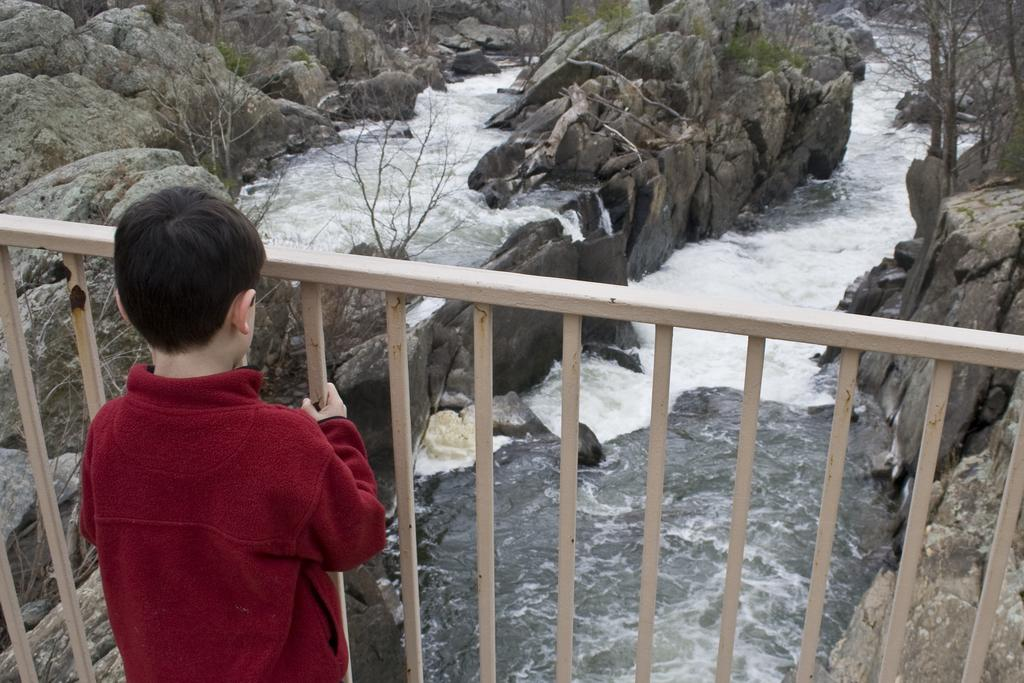Who is the main subject in the image? There is a boy in the image. What is the boy wearing? The boy is wearing a maroon color t-shirt. Where is the boy standing? The boy is standing in front of a fence. What natural features can be seen in the image? There is a hill, a tree, and a water lake visible in the image. What is the process of the boy playing baseball in the image? There is no indication of the boy playing baseball in the image, nor is there any mention of a baseball in the provided facts. 